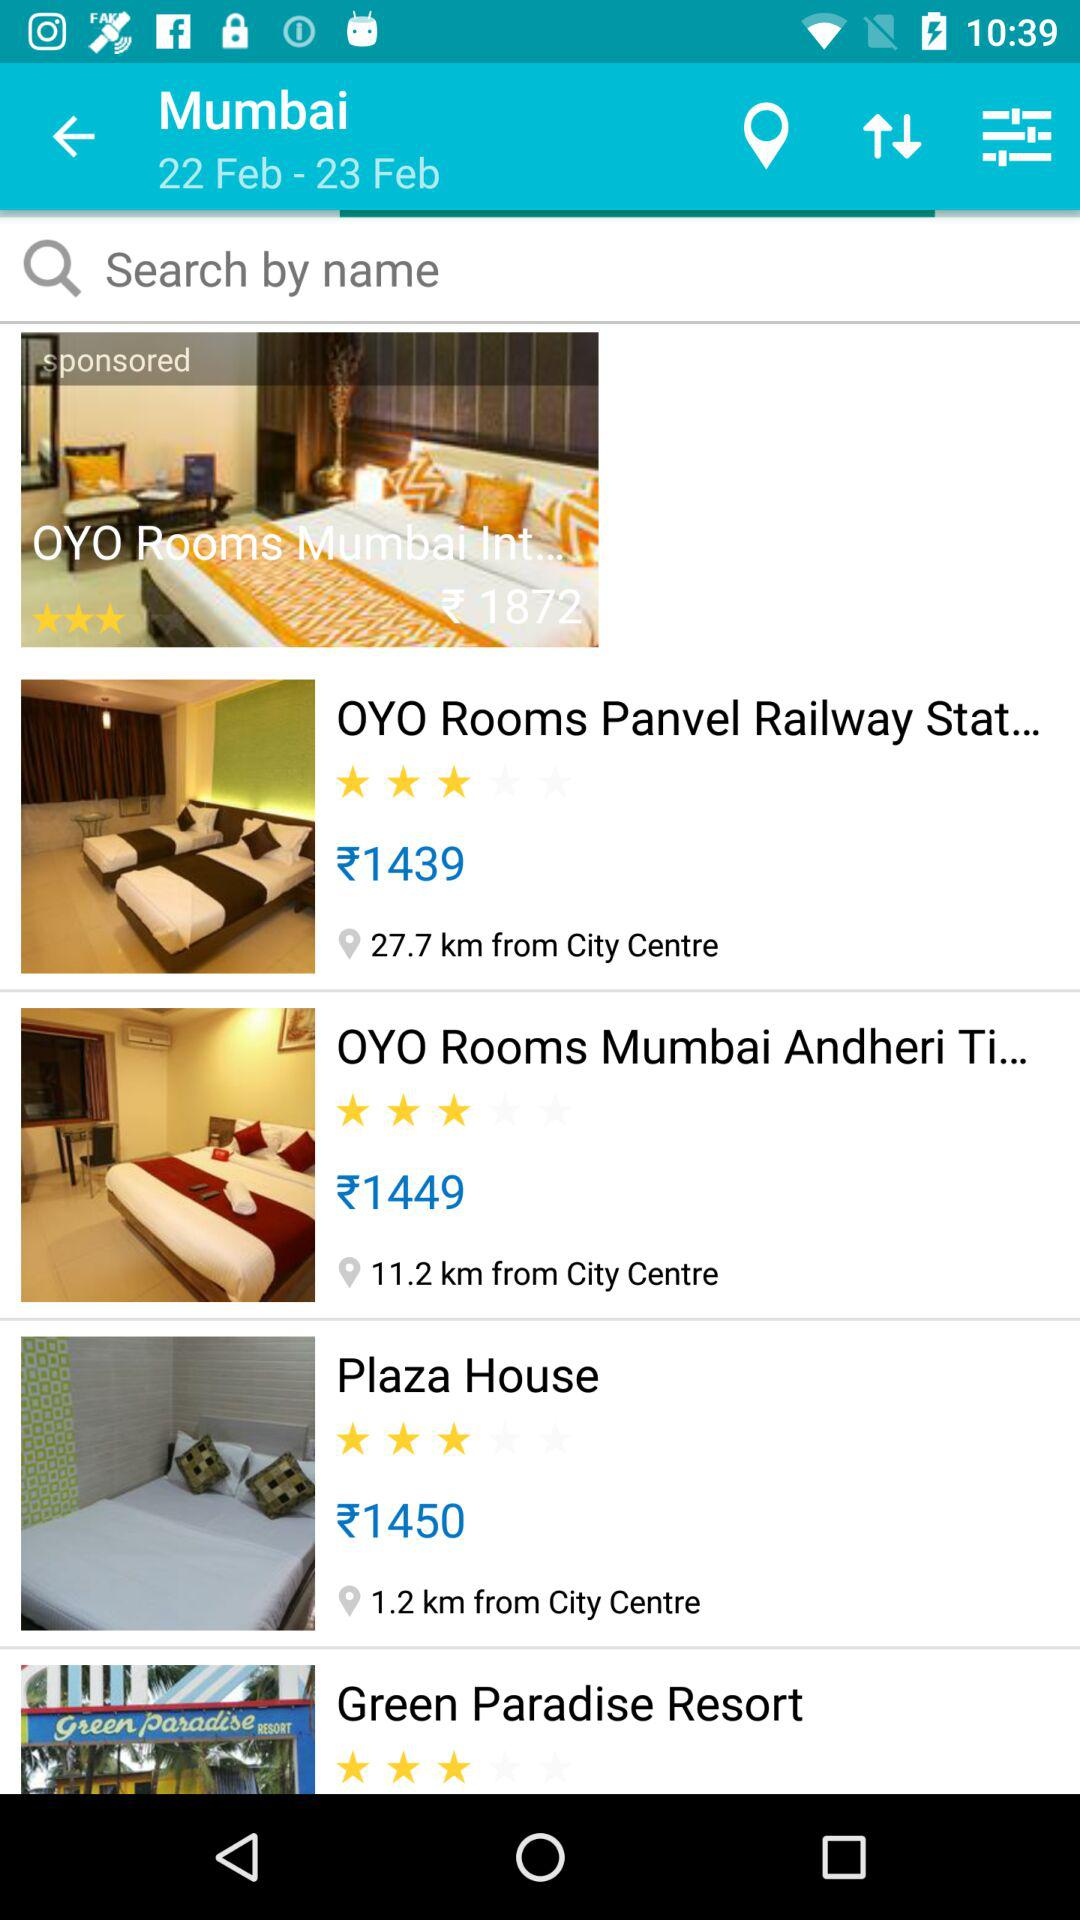Which hotel is closest to the city centre?
Answer the question using a single word or phrase. Plaza House 